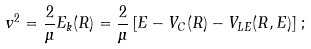Convert formula to latex. <formula><loc_0><loc_0><loc_500><loc_500>v ^ { 2 } = \frac { 2 } { \mu } E _ { k } ( R ) = \frac { 2 } { \mu } \left [ E - V _ { C } ( R ) - V _ { L E } ( R , E ) \right ] \, ;</formula> 